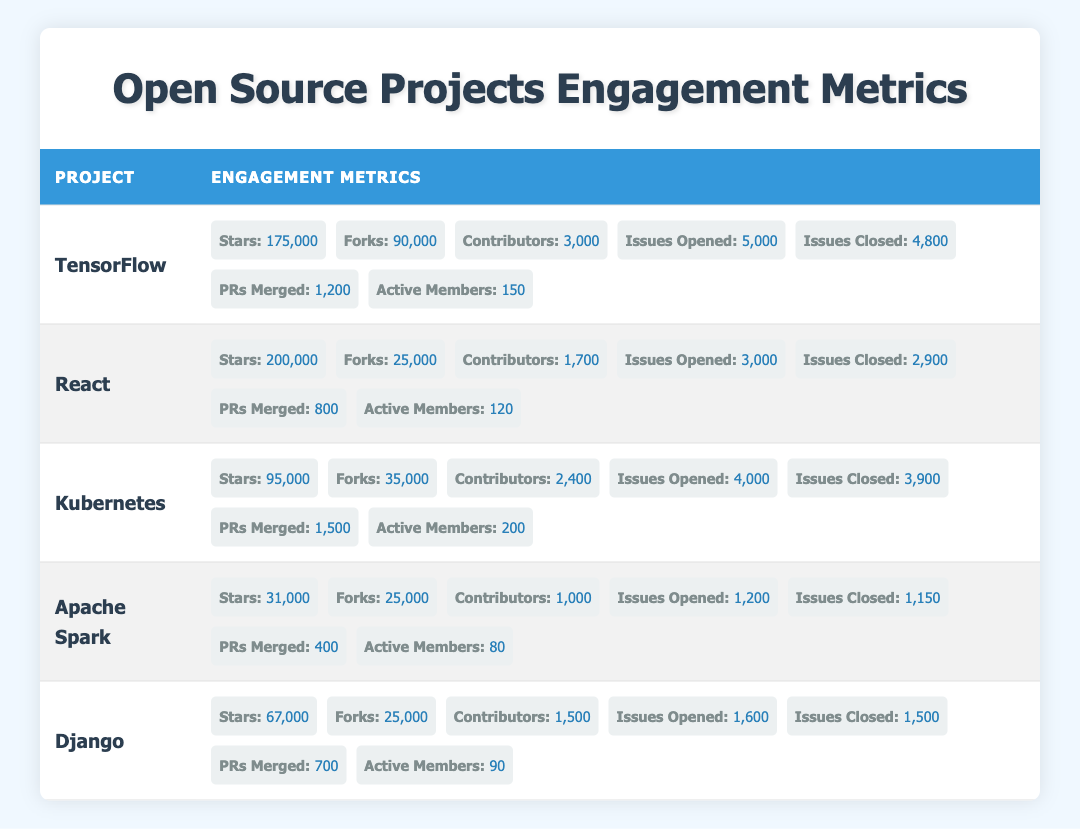What is the total number of stars for all projects listed in the table? To find the total number of stars, I need to sum the stars of each project: TensorFlow (175,000), React (200,000), Kubernetes (95,000), Apache Spark (31,000), and Django (67,000). The calculation is 175,000 + 200,000 + 95,000 + 31,000 + 67,000 = 568,000.
Answer: 568,000 How many issues were closed in total across all projects? To determine the total number of issues closed, I sum up the closed issues for each project: TensorFlow (4,800), React (2,900), Kubernetes (3,900), Apache Spark (1,150), and Django (1,500). The total is 4,800 + 2,900 + 3,900 + 1,150 + 1,500 = 14,250.
Answer: 14,250 Which project has the highest number of contributors? To find the project with the highest contributors, I compare the values for each project: TensorFlow (3,000), React (1,700), Kubernetes (2,400), Apache Spark (1,000), and Django (1,500). TensorFlow has the highest number of contributors at 3,000.
Answer: TensorFlow Is React the project with the most forks? Comparing the number of forks: TensorFlow (90,000), React (25,000), Kubernetes (35,000), Apache Spark (25,000), and Django (25,000), it is clear that TensorFlow has the most forks, not React. Therefore, the answer is no.
Answer: No What percentage of issues were closed for TensorFlow? To calculate the percentage of closed issues for TensorFlow, I take the number of closed issues (4,800) and divide it by the total opened issues (5,000), then multiply by 100. The calculation is (4,800 / 5,000) * 100 = 96%.
Answer: 96% Which project has the most active members? By comparing the number of active members: TensorFlow (150), React (120), Kubernetes (200), Apache Spark (80), and Django (90), Kubernetes has the most active members at 200.
Answer: Kubernetes What is the average number of stars for the projects listed? To find the average, I first sum the stars (568,000, calculated in a previous question) and divide by the number of projects (5). The average is 568,000 / 5 = 113,600.
Answer: 113,600 Do all projects have more than 1,000 contributors? Checking the contributors for each project: TensorFlow (3,000), React (1,700), Kubernetes (2,400), Apache Spark (1,000), and Django (1,500). Since Apache Spark has exactly 1,000, not all projects exceed 1,000 contributors. Thus, the answer is no.
Answer: No How many pull requests were merged in total across all projects? To find the total number of pull requests merged, I will sum: TensorFlow (1,200), React (800), Kubernetes (1,500), Apache Spark (400), and Django (700). The total is 1,200 + 800 + 1,500 + 400 + 700 = 4,600.
Answer: 4,600 